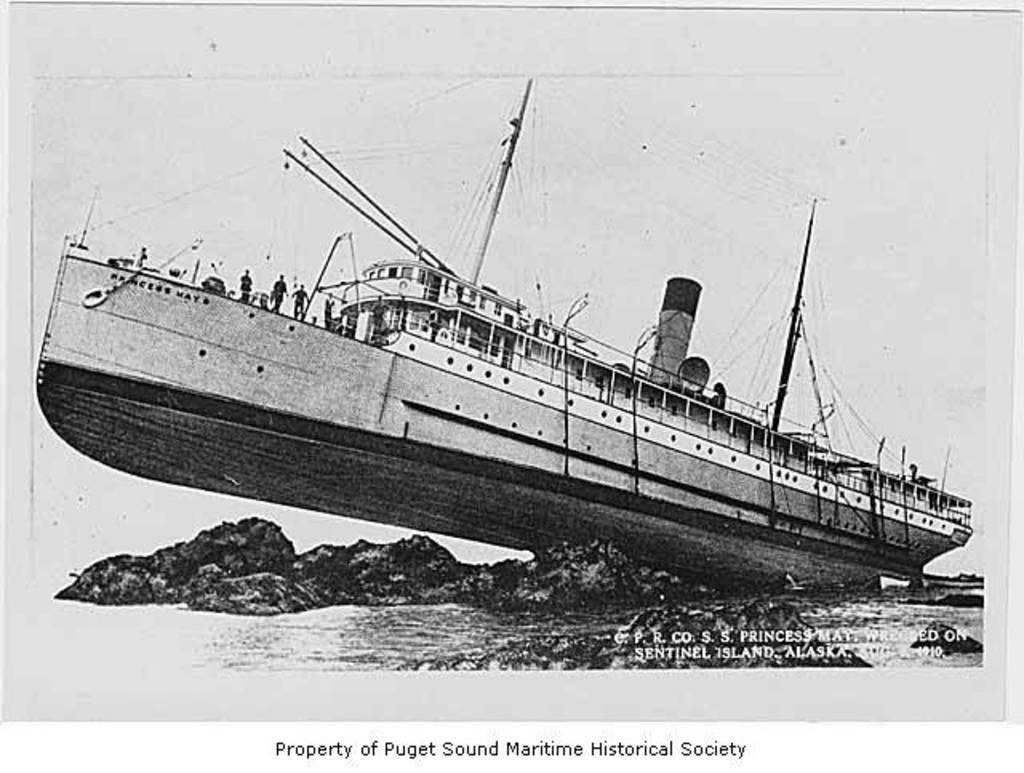What is the main subject of the paper in the image? There is a boat depicted in the center of the paper. What is located at the bottom of the paper? There is water and rocks at the bottom of the paper. Is there any text present on the paper? Yes, there is text written on the paper. Can you see a heart-shaped mountain in the image? There is no mountain, let alone a heart-shaped one, present in the image. The image features a paper with a boat, water, rocks, and text. 